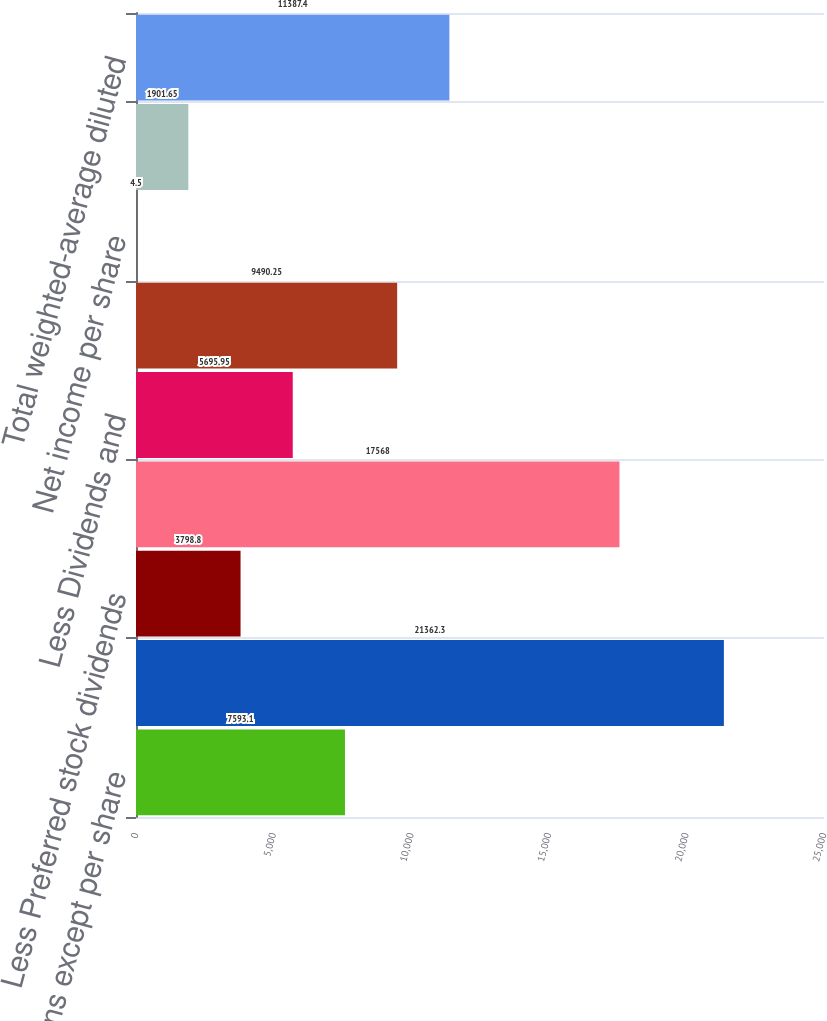Convert chart. <chart><loc_0><loc_0><loc_500><loc_500><bar_chart><fcel>(in millions except per share<fcel>Net income<fcel>Less Preferred stock dividends<fcel>Net income applicable to<fcel>Less Dividends and<fcel>Total weighted-average basic<fcel>Net income per share<fcel>Add Employee stock options<fcel>Total weighted-average diluted<nl><fcel>7593.1<fcel>21362.3<fcel>3798.8<fcel>17568<fcel>5695.95<fcel>9490.25<fcel>4.5<fcel>1901.65<fcel>11387.4<nl></chart> 